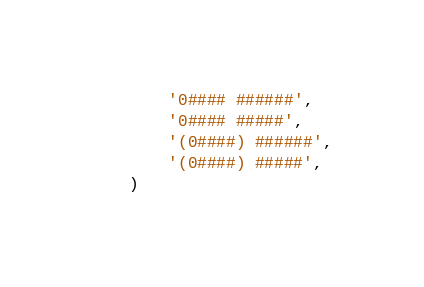<code> <loc_0><loc_0><loc_500><loc_500><_Python_>        '0#### ######',
        '0#### #####',
        '(0####) ######',
        '(0####) #####',
    )
</code> 